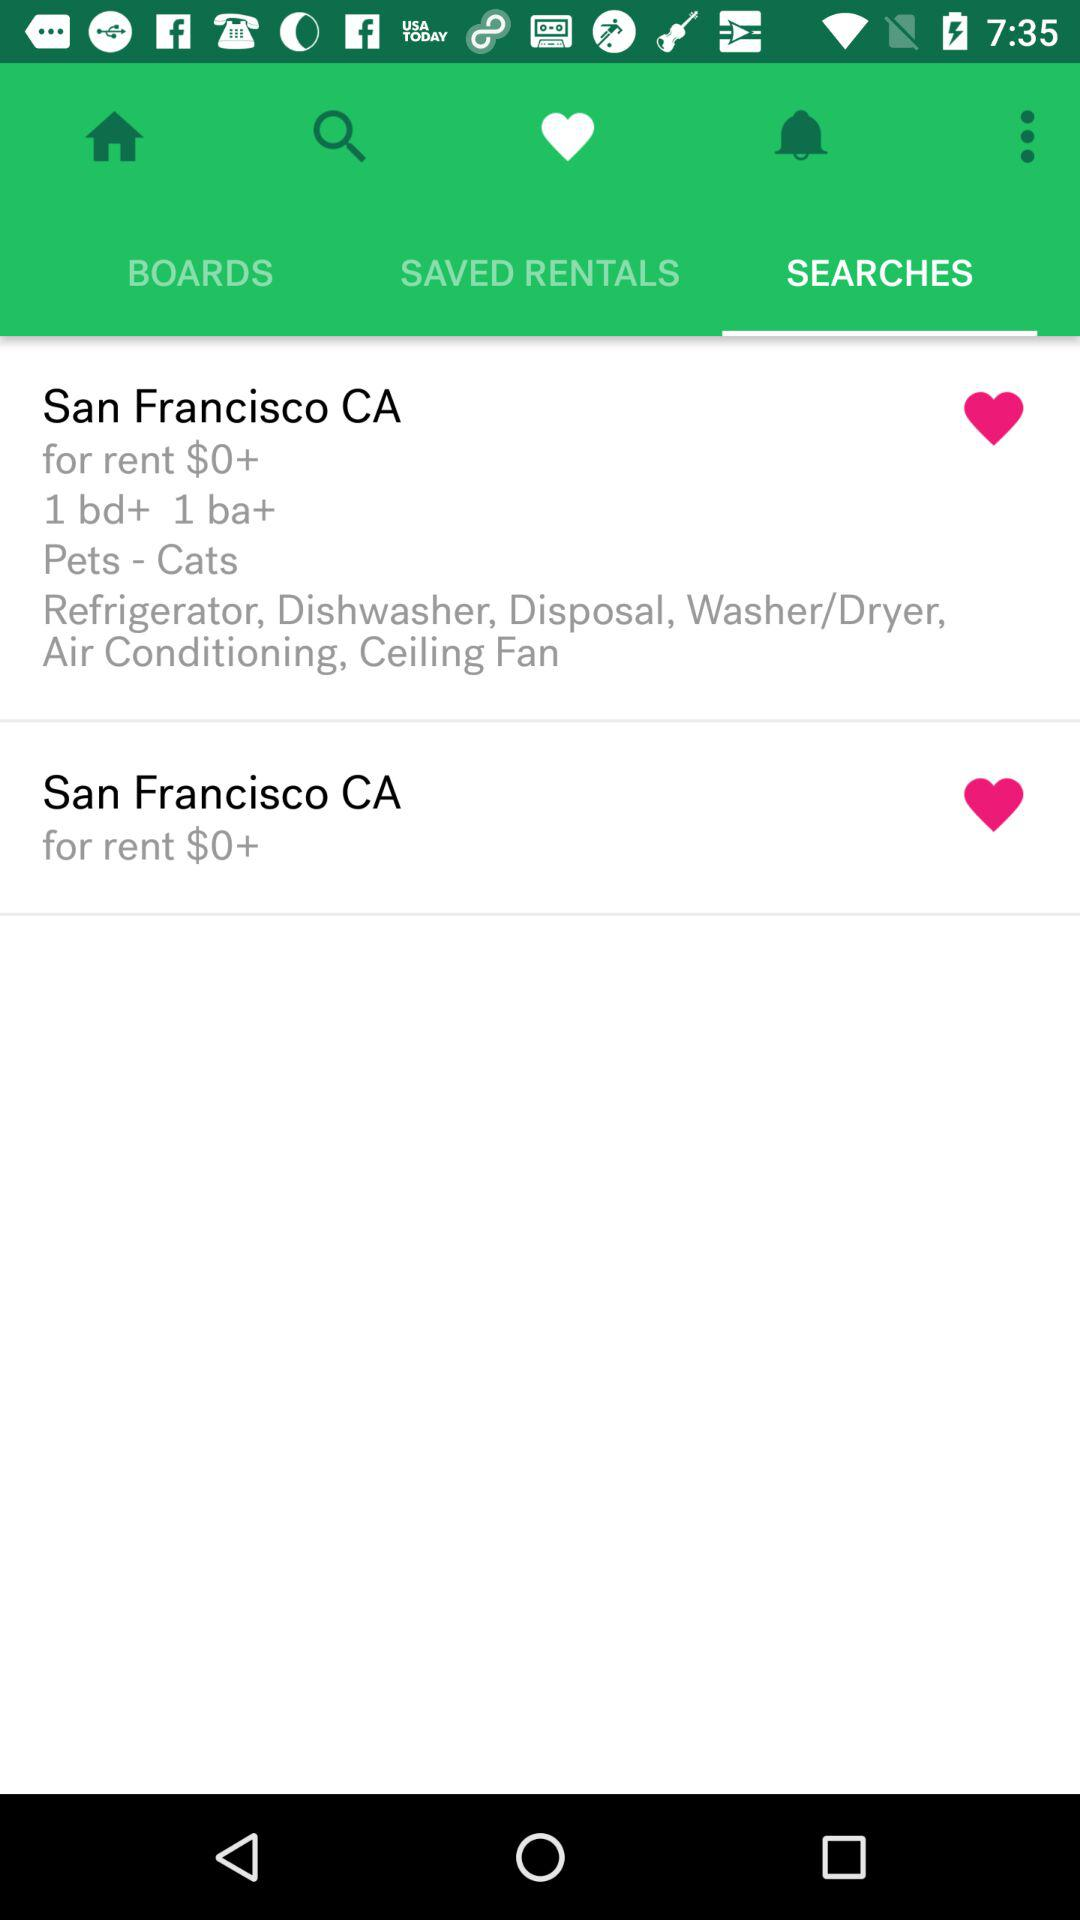Which tab is selected? The selected tabs are "Favourites" and "SEARCHES". 